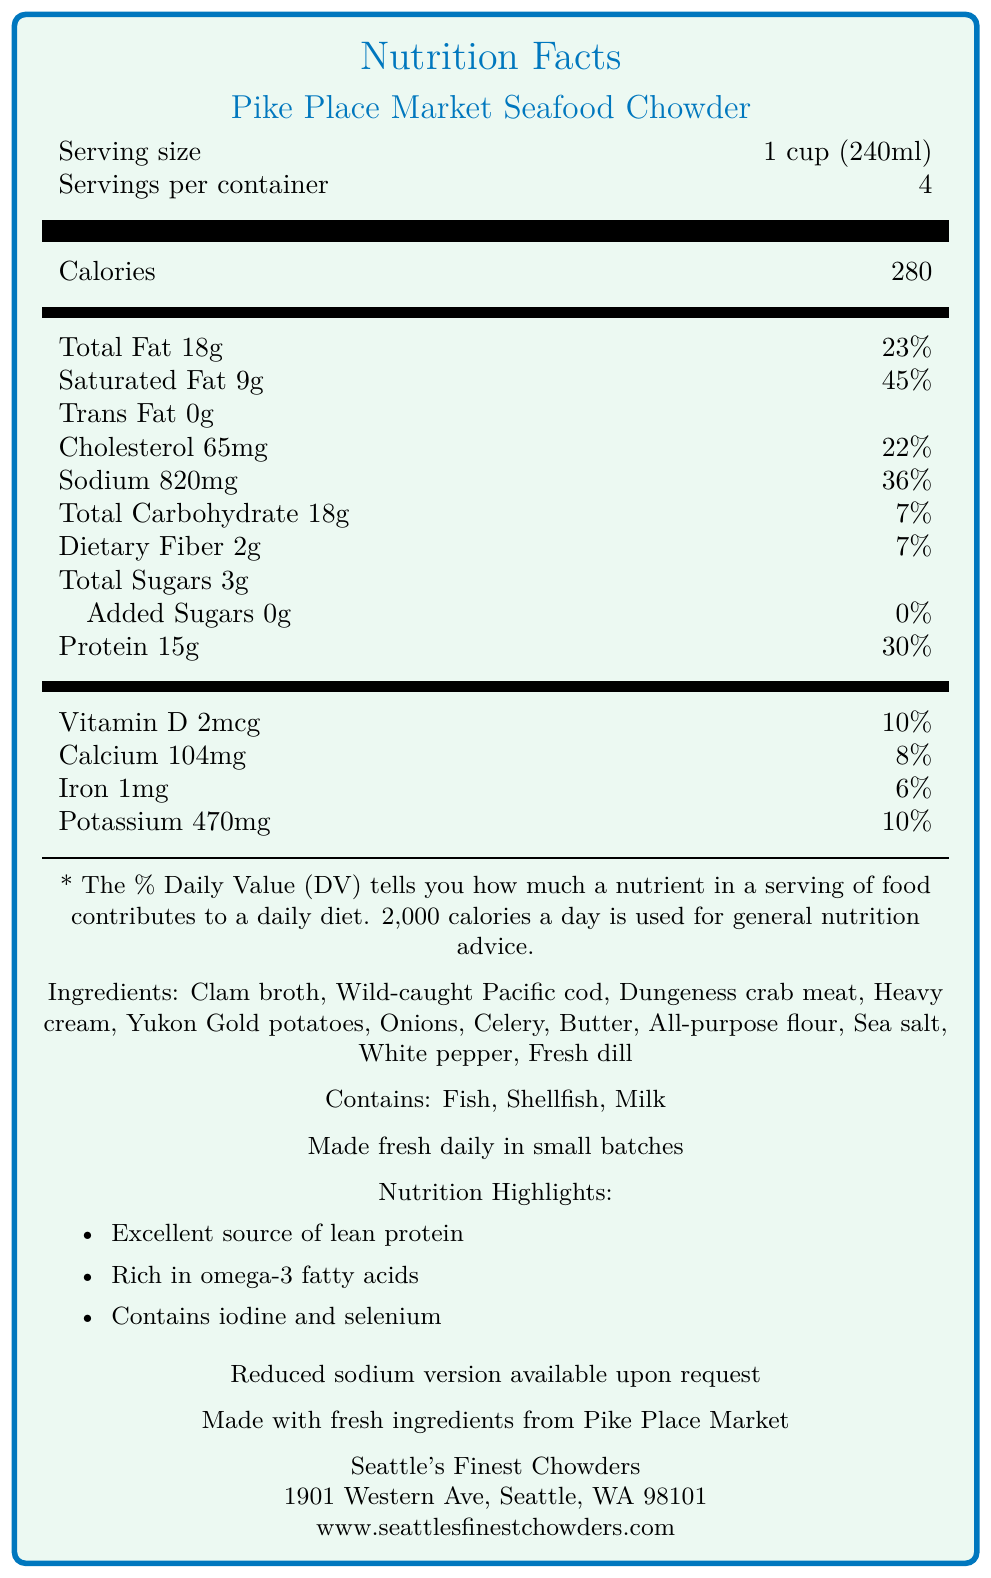What is the serving size for Pike Place Market Seafood Chowder? The document specifies that the serving size is 1 cup (240ml).
Answer: 1 cup (240ml) How many servings are per container of the chowder? According to the document, there are 4 servings per container.
Answer: 4 What percentage of the daily value for sodium does one serving provide? The nutrition facts list sodium at 820mg, which accounts for 36% of the daily value.
Answer: 36% How much protein is in one serving of the chowder? The document states that one serving contains 15 grams of protein.
Answer: 15g Is there a reduced sodium version of the chowder available? The document includes a note that a reduced sodium version is available upon request.
Answer: Yes What type of seafood is included in the ingredients of the chowder? A. Salmon B. Tuna C. Cod D. Shrimp The ingredients list includes "Wild-caught Pacific cod" as one of the types of seafood.
Answer: C Which of the following nutrients is NOT a part of the nutrition highlights? A. Omega-3 fatty acids B. Antioxidants C. Selenium D. Iodine Under nutrition highlights, omega-3 fatty acids, selenium, and iodine are mentioned, but antioxidants are not.
Answer: B Does the chowder contain any added sugars? The nutrition facts specify that there are 0 grams of added sugars in the chowder.
Answer: No Summarize the document's nutritional information and details about the chowder. This answer gives a detailed overview of the nutritional information along with the preparation and key highlights regarding the chowder.
Answer: The Pike Place Market Seafood Chowder provides nutritional information for each serving (1 cup or 240ml) with 280 calories, 18g of total fat, 9g of saturated fat, 0g of trans fat, 65mg of cholesterol, 820mg of sodium, 18g of carbohydrates, 2g dietary fiber, 3g total sugars, and 15g of protein. It also includes essential vitamins and minerals. The ingredients are primarily seafood-based from sustainable sources, and it’s made fresh daily with a note on a reduced sodium option available. Based on the percentages provided, which nutrient contributes the highest percentage of the daily value? The document shows that with 9g of saturated fat, the chowder contributes 45% of the daily value, which is the highest percentage mentioned.
Answer: Saturated Fat What is the primary source of protein in the chowder? The protein source is noted to be "15g of protein primarily from sustainably sourced seafood," highlighting its sustainability focus.
Answer: Sustainably sourced seafood What is the address of the company that produces this chowder? The company information section provides this specific address.
Answer: 1901 Western Ave, Seattle, WA 98101 What certifications does the chowder have? The document lists these two certifications under the certifications section.
Answer: Sustainable Seafood Certified and Washington State Department of Health Approved Is the document providing sufficient information about the exact calorie breakdown from fats, proteins, and carbohydrates? The document provides calorie content but does not break down the calories specifically from fats, proteins, and carbohydrates.
Answer: No What ingredients make the chowder creamy? A. Butter and flour B. Heavy cream and butter C. Clam broth and potatoes D. Onions and celery The listed ingredients include heavy cream and butter, both of which contribute to the creamy texture.
Answer: B 